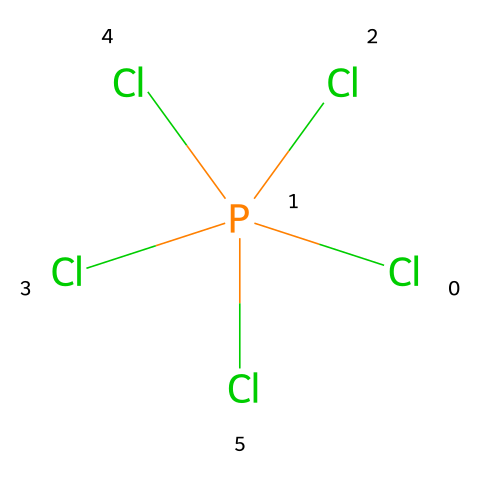What is the molecular formula of this chemical? The chemical structure has one phosphorus atom and five chlorine atoms. Thus, the molecular formula can be represented as PCl5.
Answer: PCl5 How many chlorine atoms are present in phosphorus pentachloride? Analyzing the SMILES representation reveals five chlorine (Cl) symbols, indicating there are five chlorine atoms within the molecule.
Answer: five What type of compound is phosphorus pentachloride? Phosphorus pentachloride, due to its phosphorus atom that expands its valence shell, is categorized as a hypervalent compound.
Answer: hypervalent Is phosphorus pentachloride ionic or covalent? Given that phosphorus pentachloride consists of covalent bonds between phosphorus and chlorine, it is classified as a covalent compound.
Answer: covalent Why is phosphorus pentachloride considered to have a hypervalent phosphorus atom? The phosphorus atom can accommodate more than eight electrons in its outer shell due to its ability to utilize d-orbitals, thus allowing five bonding pairs with chlorine, which is characteristic of hypervalent structures.
Answer: hypervalent What role does phosphorus pentachloride play in flame retardants? Phosphorus pentachloride acts as a flame retardant due to its ability to release chlorine, which inhibits the combustion process by preventing the propagation of flame.
Answer: flame retardant 